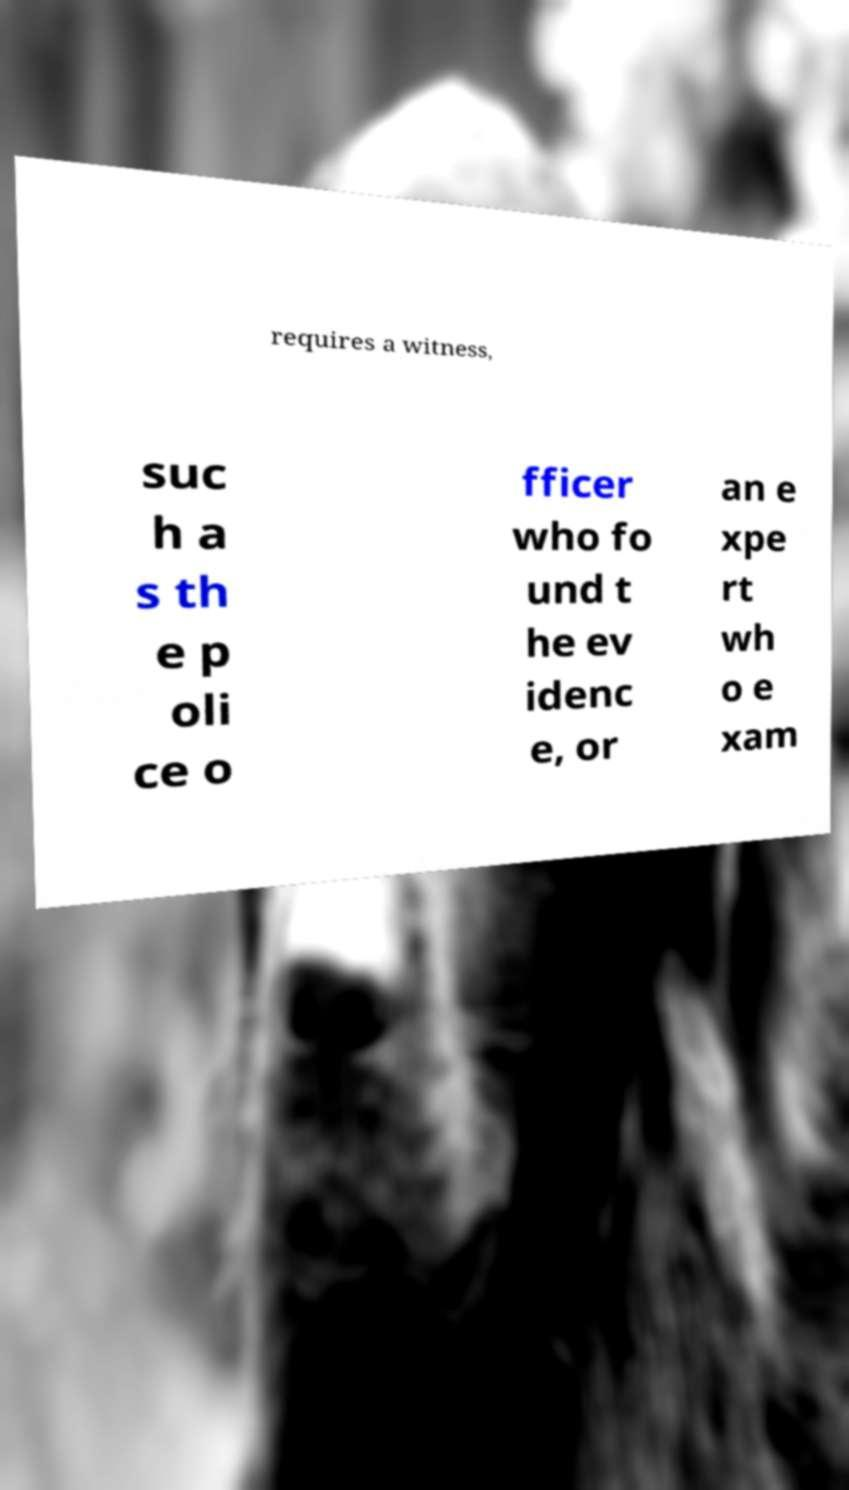Could you assist in decoding the text presented in this image and type it out clearly? requires a witness, suc h a s th e p oli ce o fficer who fo und t he ev idenc e, or an e xpe rt wh o e xam 